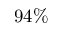<formula> <loc_0><loc_0><loc_500><loc_500>9 4 \%</formula> 